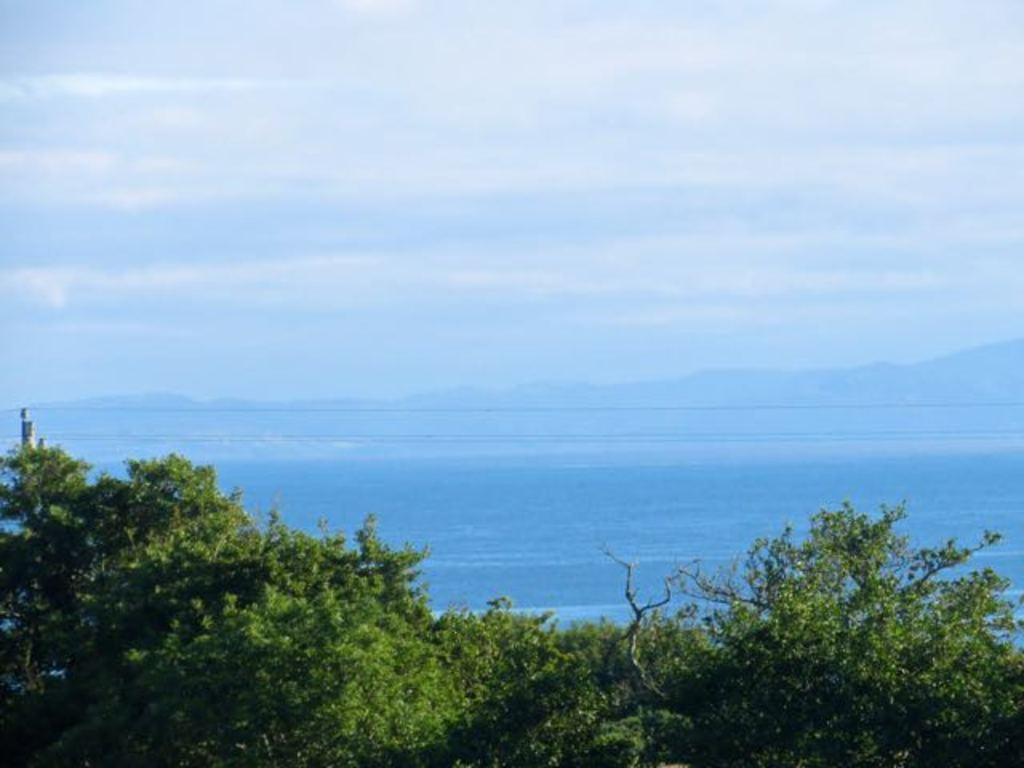Can you describe this image briefly? At the bottom of the image there are trees. There is water. In the background of the image there are mountains. At the top of the image there is sky. 